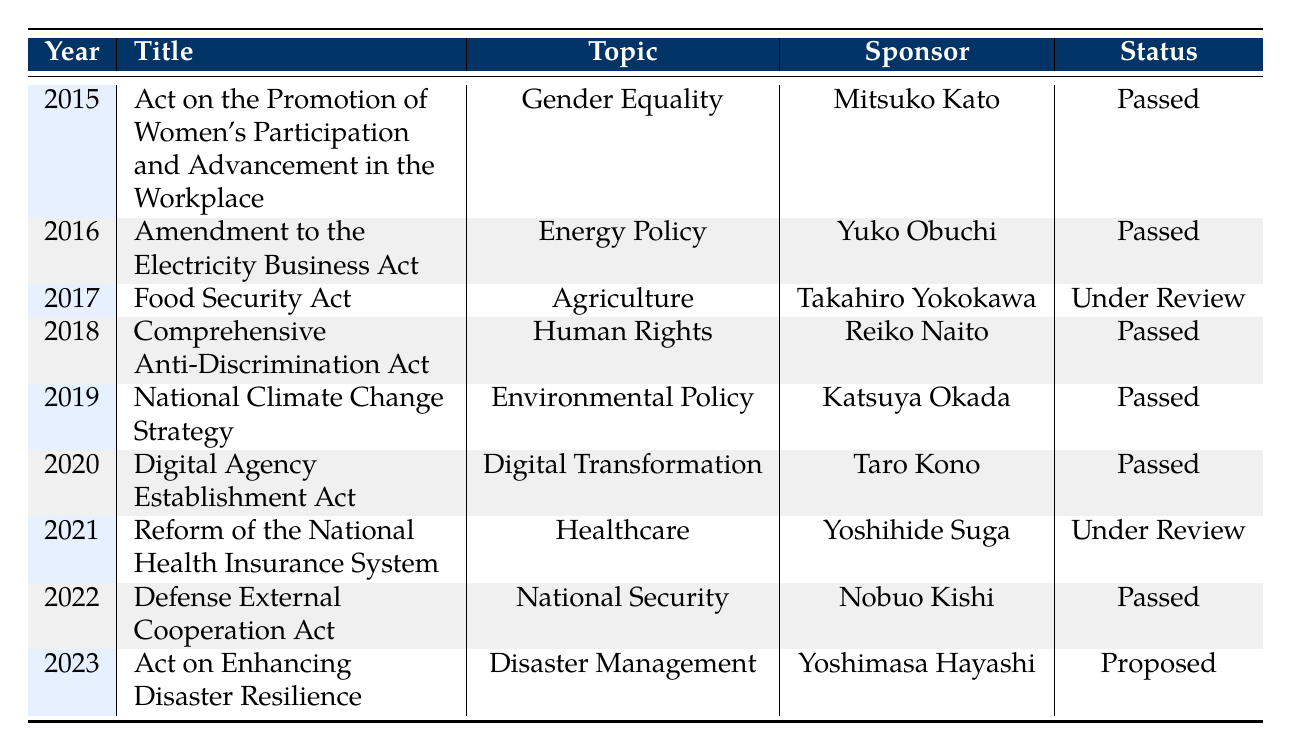What legislative bill was introduced in 2019? The table indicates that the legislative bill introduced in 2019 is the "National Climate Change Strategy."
Answer: National Climate Change Strategy Who sponsored the Act on the Promotion of Women's Participation and Advancement in the Workplace? According to the table, Mitsuko Kato sponsored the Act on the Promotion of Women's Participation and Advancement in the Workplace.
Answer: Mitsuko Kato In which year was the Digital Agency Establishment Act passed? The table shows that the Digital Agency Establishment Act was passed in 2020.
Answer: 2020 How many bills are Under Review? From the table, there are two bills marked as Under Review: the Food Security Act from 2017 and the Reform of the National Health Insurance System from 2021. This total is 2.
Answer: 2 Was the Comprehensive Anti-Discrimination Act proposed or passed? The table indicates that the Comprehensive Anti-Discrimination Act was passed in 2018.
Answer: Passed What is the topic of the bill that is currently proposed? The table reveals that the "Act on Enhancing Disaster Resilience" is the bill that is currently proposed in 2023.
Answer: Disaster Management What is the total number of bills passed from 2015 to 2022? By counting from the table, we see that the passed bills are: Women's Participation Act (2015), Electricity Business Act (2016), Comprehensive Anti-Discrimination Act (2018), National Climate Change Strategy (2019), Digital Agency Establishment Act (2020), and Defense External Cooperation Act (2022). This totals to 6 bills passed.
Answer: 6 What legislative topic had a proposed status in 2023? The table shows that the topic "Disaster Management" is represented by the Act on Enhancing Disaster Resilience, which is currently proposed in 2023.
Answer: Disaster Management Which bill had the sponsor Yoshihide Suga? According to the data, the bill sponsored by Yoshihide Suga is the "Reform of the National Health Insurance System," which is under review.
Answer: Reform of the National Health Insurance System 